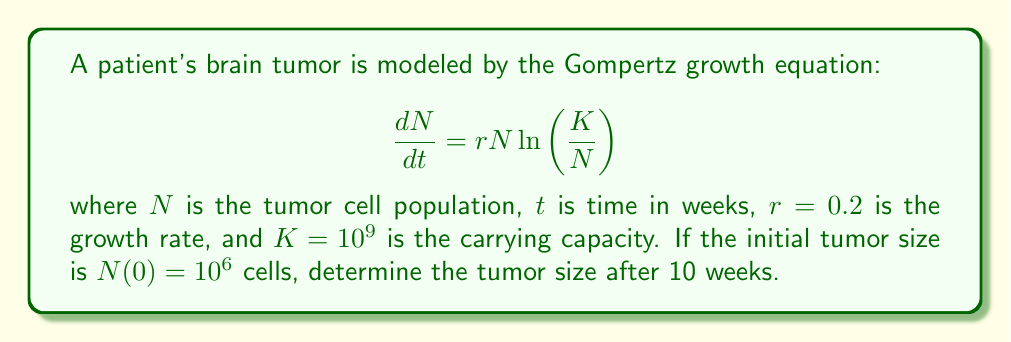Can you solve this math problem? To solve this nonlinear differential equation, we follow these steps:

1) The Gompertz equation has the general solution:

   $$N(t) = Ke^{\ln(N_0/K)e^{-rt}}$$

   where $N_0$ is the initial population.

2) We're given:
   $K = 10^9$
   $r = 0.2$
   $N_0 = 10^6$
   $t = 10$

3) Let's substitute these values into the solution:

   $$N(10) = 10^9 \cdot e^{\ln(10^6/10^9)e^{-0.2 \cdot 10}}$$

4) Simplify inside the parentheses:
   
   $$N(10) = 10^9 \cdot e^{\ln(10^{-3})e^{-2}}$$

5) Simplify the logarithm:
   
   $$N(10) = 10^9 \cdot e^{-3\ln(10)e^{-2}}$$

6) Calculate $e^{-2} \approx 0.1353$:
   
   $$N(10) = 10^9 \cdot e^{-3\ln(10) \cdot 0.1353}$$

7) Simplify:
   
   $$N(10) = 10^9 \cdot e^{-0.9344}$$

8) Calculate the final result:
   
   $$N(10) \approx 3.93 \times 10^8$$
Answer: $3.93 \times 10^8$ cells 